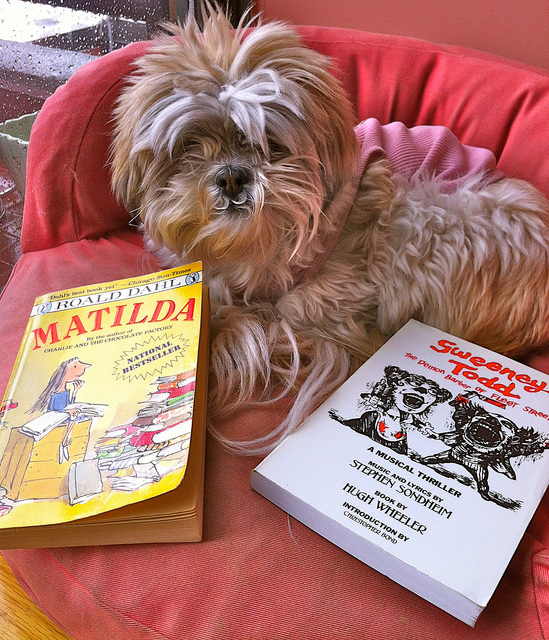Read all the text in this image. ROALD DAHL MATILDA BESTSELLER NATIONAL Todd CHOCOLATE BOND INTRODUCTION BY INTRODUCTION WHEELER MUGH BY BOOK SONDHEIM STEPHEN LYRICS AND MUSIC THRILLER MUSICAL A STRONG Floet Sweeney Todd 